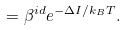<formula> <loc_0><loc_0><loc_500><loc_500>= \beta ^ { i d } e ^ { - \Delta I / k _ { B } T } .</formula> 